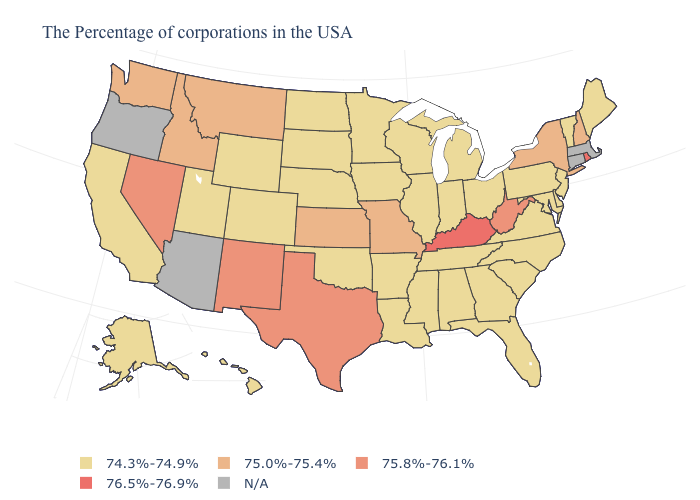Is the legend a continuous bar?
Answer briefly. No. What is the value of Alaska?
Answer briefly. 74.3%-74.9%. Among the states that border Colorado , does Kansas have the lowest value?
Give a very brief answer. No. Which states have the lowest value in the West?
Concise answer only. Wyoming, Colorado, Utah, California, Alaska, Hawaii. Does the map have missing data?
Write a very short answer. Yes. What is the value of Iowa?
Keep it brief. 74.3%-74.9%. Name the states that have a value in the range 76.5%-76.9%?
Concise answer only. Rhode Island, Kentucky. Name the states that have a value in the range N/A?
Write a very short answer. Massachusetts, Connecticut, Arizona, Oregon. Name the states that have a value in the range 76.5%-76.9%?
Keep it brief. Rhode Island, Kentucky. Name the states that have a value in the range 75.0%-75.4%?
Keep it brief. New Hampshire, New York, Missouri, Kansas, Montana, Idaho, Washington. What is the highest value in the South ?
Keep it brief. 76.5%-76.9%. Does the map have missing data?
Concise answer only. Yes. What is the lowest value in states that border Kansas?
Write a very short answer. 74.3%-74.9%. What is the lowest value in the USA?
Be succinct. 74.3%-74.9%. 